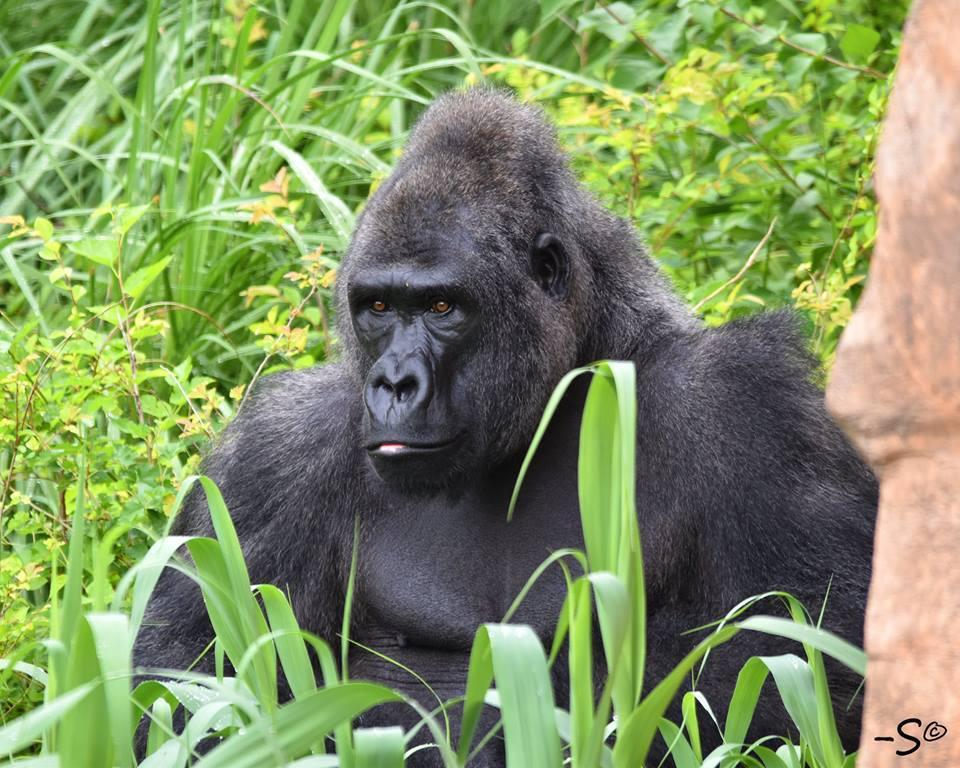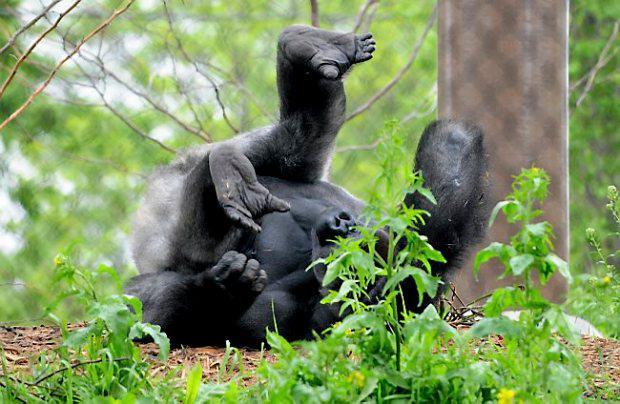The first image is the image on the left, the second image is the image on the right. Given the left and right images, does the statement "One image contains twice as many apes as the other image and includes a baby gorilla." hold true? Answer yes or no. No. The first image is the image on the left, the second image is the image on the right. For the images shown, is this caption "There are exactly two gorillas in total." true? Answer yes or no. Yes. 